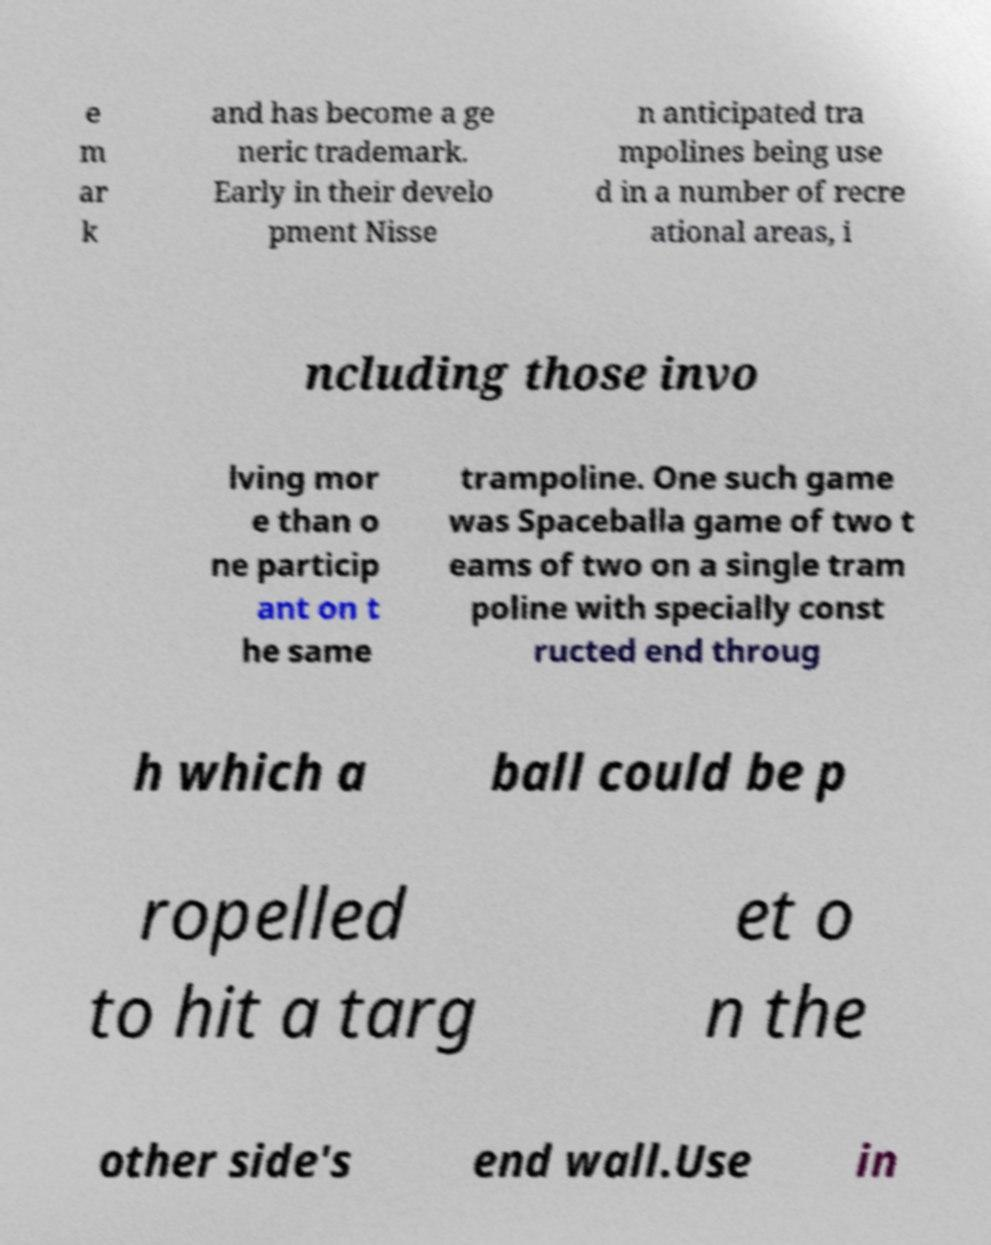Could you extract and type out the text from this image? e m ar k and has become a ge neric trademark. Early in their develo pment Nisse n anticipated tra mpolines being use d in a number of recre ational areas, i ncluding those invo lving mor e than o ne particip ant on t he same trampoline. One such game was Spaceballa game of two t eams of two on a single tram poline with specially const ructed end throug h which a ball could be p ropelled to hit a targ et o n the other side's end wall.Use in 